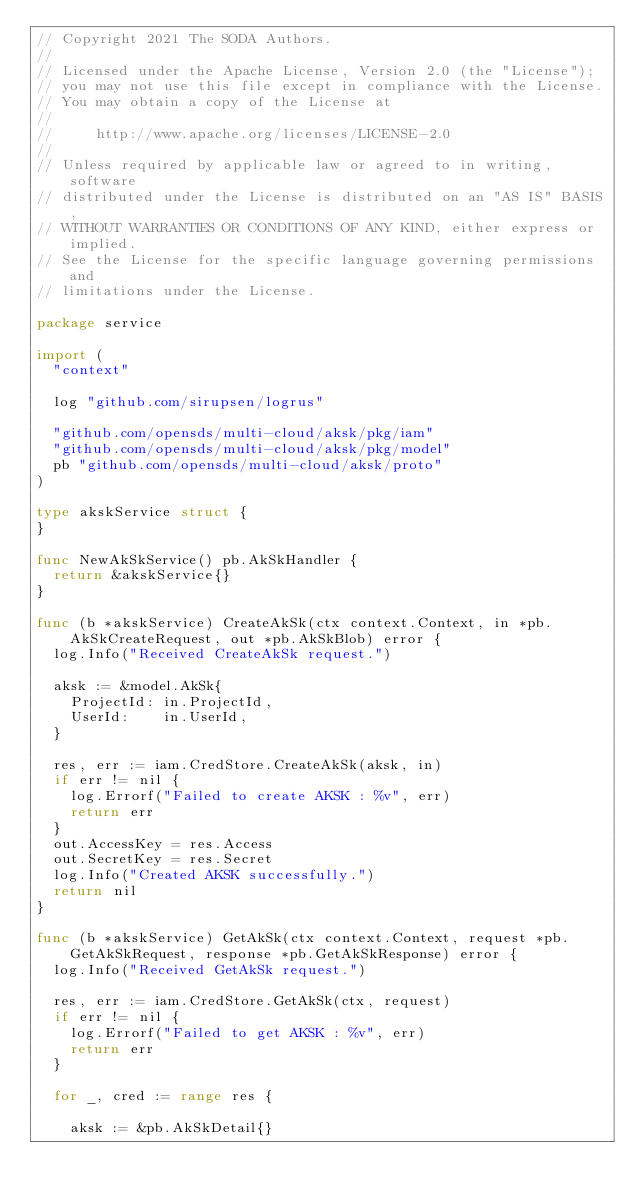<code> <loc_0><loc_0><loc_500><loc_500><_Go_>// Copyright 2021 The SODA Authors.
//
// Licensed under the Apache License, Version 2.0 (the "License");
// you may not use this file except in compliance with the License.
// You may obtain a copy of the License at
//
//     http://www.apache.org/licenses/LICENSE-2.0
//
// Unless required by applicable law or agreed to in writing, software
// distributed under the License is distributed on an "AS IS" BASIS,
// WITHOUT WARRANTIES OR CONDITIONS OF ANY KIND, either express or implied.
// See the License for the specific language governing permissions and
// limitations under the License.

package service

import (
	"context"

	log "github.com/sirupsen/logrus"

	"github.com/opensds/multi-cloud/aksk/pkg/iam"
	"github.com/opensds/multi-cloud/aksk/pkg/model"
	pb "github.com/opensds/multi-cloud/aksk/proto"
)

type akskService struct {
}

func NewAkSkService() pb.AkSkHandler {
	return &akskService{}
}

func (b *akskService) CreateAkSk(ctx context.Context, in *pb.AkSkCreateRequest, out *pb.AkSkBlob) error {
	log.Info("Received CreateAkSk request.")

	aksk := &model.AkSk{
		ProjectId: in.ProjectId,
		UserId:    in.UserId,
	}

	res, err := iam.CredStore.CreateAkSk(aksk, in)
	if err != nil {
		log.Errorf("Failed to create AKSK : %v", err)
		return err
	}
	out.AccessKey = res.Access
	out.SecretKey = res.Secret
	log.Info("Created AKSK successfully.")
	return nil
}

func (b *akskService) GetAkSk(ctx context.Context, request *pb.GetAkSkRequest, response *pb.GetAkSkResponse) error {
	log.Info("Received GetAkSk request.")

	res, err := iam.CredStore.GetAkSk(ctx, request)
	if err != nil {
		log.Errorf("Failed to get AKSK : %v", err)
		return err
	}

	for _, cred := range res {

		aksk := &pb.AkSkDetail{}</code> 